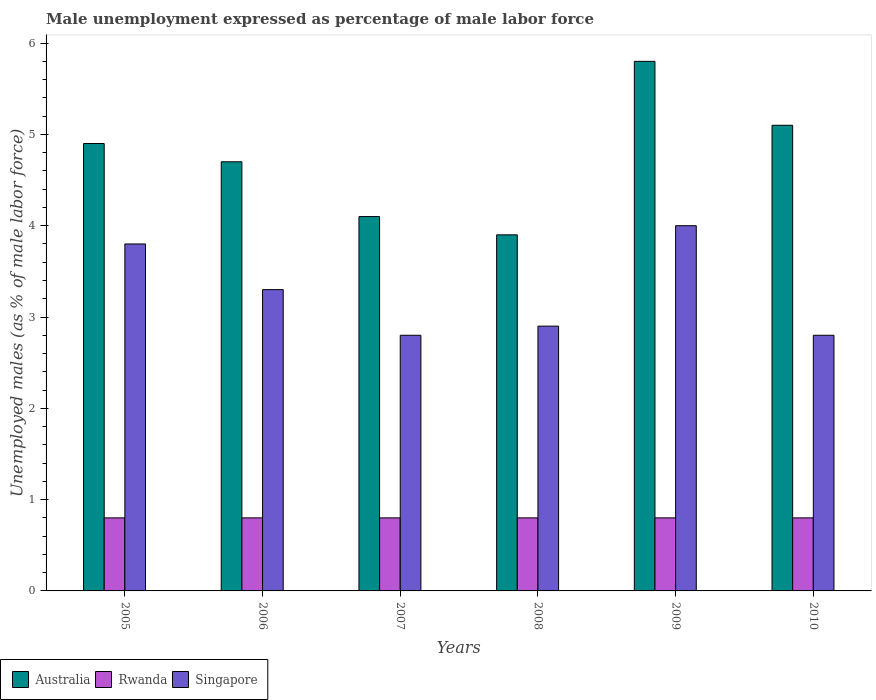How many groups of bars are there?
Offer a very short reply. 6. Are the number of bars per tick equal to the number of legend labels?
Offer a terse response. Yes. Are the number of bars on each tick of the X-axis equal?
Offer a very short reply. Yes. How many bars are there on the 3rd tick from the right?
Ensure brevity in your answer.  3. What is the label of the 2nd group of bars from the left?
Provide a succinct answer. 2006. What is the unemployment in males in in Australia in 2006?
Provide a short and direct response. 4.7. Across all years, what is the maximum unemployment in males in in Rwanda?
Keep it short and to the point. 0.8. Across all years, what is the minimum unemployment in males in in Singapore?
Offer a very short reply. 2.8. What is the total unemployment in males in in Rwanda in the graph?
Your response must be concise. 4.8. What is the difference between the unemployment in males in in Australia in 2005 and that in 2006?
Provide a short and direct response. 0.2. What is the difference between the unemployment in males in in Rwanda in 2007 and the unemployment in males in in Singapore in 2009?
Your response must be concise. -3.2. What is the average unemployment in males in in Rwanda per year?
Your answer should be compact. 0.8. In the year 2006, what is the difference between the unemployment in males in in Singapore and unemployment in males in in Australia?
Your answer should be compact. -1.4. In how many years, is the unemployment in males in in Singapore greater than 5 %?
Offer a very short reply. 0. What is the ratio of the unemployment in males in in Singapore in 2006 to that in 2010?
Provide a short and direct response. 1.18. Is the difference between the unemployment in males in in Singapore in 2007 and 2008 greater than the difference between the unemployment in males in in Australia in 2007 and 2008?
Keep it short and to the point. No. What is the difference between the highest and the second highest unemployment in males in in Singapore?
Provide a short and direct response. 0.2. What is the difference between the highest and the lowest unemployment in males in in Rwanda?
Give a very brief answer. 0. Is the sum of the unemployment in males in in Rwanda in 2006 and 2008 greater than the maximum unemployment in males in in Singapore across all years?
Offer a very short reply. No. What does the 2nd bar from the left in 2006 represents?
Provide a succinct answer. Rwanda. Is it the case that in every year, the sum of the unemployment in males in in Australia and unemployment in males in in Singapore is greater than the unemployment in males in in Rwanda?
Offer a very short reply. Yes. How many bars are there?
Give a very brief answer. 18. Are all the bars in the graph horizontal?
Provide a short and direct response. No. Are the values on the major ticks of Y-axis written in scientific E-notation?
Provide a short and direct response. No. Does the graph contain grids?
Ensure brevity in your answer.  No. How many legend labels are there?
Ensure brevity in your answer.  3. How are the legend labels stacked?
Offer a terse response. Horizontal. What is the title of the graph?
Provide a succinct answer. Male unemployment expressed as percentage of male labor force. What is the label or title of the X-axis?
Make the answer very short. Years. What is the label or title of the Y-axis?
Keep it short and to the point. Unemployed males (as % of male labor force). What is the Unemployed males (as % of male labor force) of Australia in 2005?
Keep it short and to the point. 4.9. What is the Unemployed males (as % of male labor force) in Rwanda in 2005?
Offer a very short reply. 0.8. What is the Unemployed males (as % of male labor force) of Singapore in 2005?
Provide a short and direct response. 3.8. What is the Unemployed males (as % of male labor force) in Australia in 2006?
Offer a terse response. 4.7. What is the Unemployed males (as % of male labor force) of Rwanda in 2006?
Your answer should be compact. 0.8. What is the Unemployed males (as % of male labor force) in Singapore in 2006?
Provide a succinct answer. 3.3. What is the Unemployed males (as % of male labor force) in Australia in 2007?
Your response must be concise. 4.1. What is the Unemployed males (as % of male labor force) in Rwanda in 2007?
Ensure brevity in your answer.  0.8. What is the Unemployed males (as % of male labor force) in Singapore in 2007?
Give a very brief answer. 2.8. What is the Unemployed males (as % of male labor force) in Australia in 2008?
Provide a succinct answer. 3.9. What is the Unemployed males (as % of male labor force) of Rwanda in 2008?
Your answer should be very brief. 0.8. What is the Unemployed males (as % of male labor force) in Singapore in 2008?
Your answer should be very brief. 2.9. What is the Unemployed males (as % of male labor force) in Australia in 2009?
Make the answer very short. 5.8. What is the Unemployed males (as % of male labor force) in Rwanda in 2009?
Provide a succinct answer. 0.8. What is the Unemployed males (as % of male labor force) of Australia in 2010?
Give a very brief answer. 5.1. What is the Unemployed males (as % of male labor force) in Rwanda in 2010?
Offer a terse response. 0.8. What is the Unemployed males (as % of male labor force) in Singapore in 2010?
Offer a very short reply. 2.8. Across all years, what is the maximum Unemployed males (as % of male labor force) of Australia?
Provide a succinct answer. 5.8. Across all years, what is the maximum Unemployed males (as % of male labor force) in Rwanda?
Ensure brevity in your answer.  0.8. Across all years, what is the minimum Unemployed males (as % of male labor force) in Australia?
Provide a succinct answer. 3.9. Across all years, what is the minimum Unemployed males (as % of male labor force) of Rwanda?
Provide a short and direct response. 0.8. Across all years, what is the minimum Unemployed males (as % of male labor force) in Singapore?
Offer a very short reply. 2.8. What is the total Unemployed males (as % of male labor force) in Australia in the graph?
Offer a very short reply. 28.5. What is the total Unemployed males (as % of male labor force) in Singapore in the graph?
Your response must be concise. 19.6. What is the difference between the Unemployed males (as % of male labor force) of Rwanda in 2005 and that in 2006?
Provide a succinct answer. 0. What is the difference between the Unemployed males (as % of male labor force) in Australia in 2005 and that in 2007?
Make the answer very short. 0.8. What is the difference between the Unemployed males (as % of male labor force) in Singapore in 2005 and that in 2007?
Offer a very short reply. 1. What is the difference between the Unemployed males (as % of male labor force) in Australia in 2005 and that in 2009?
Provide a succinct answer. -0.9. What is the difference between the Unemployed males (as % of male labor force) in Rwanda in 2005 and that in 2009?
Offer a very short reply. 0. What is the difference between the Unemployed males (as % of male labor force) of Singapore in 2005 and that in 2009?
Your answer should be very brief. -0.2. What is the difference between the Unemployed males (as % of male labor force) in Singapore in 2006 and that in 2007?
Make the answer very short. 0.5. What is the difference between the Unemployed males (as % of male labor force) of Australia in 2006 and that in 2008?
Your answer should be very brief. 0.8. What is the difference between the Unemployed males (as % of male labor force) in Australia in 2006 and that in 2009?
Ensure brevity in your answer.  -1.1. What is the difference between the Unemployed males (as % of male labor force) of Rwanda in 2006 and that in 2009?
Make the answer very short. 0. What is the difference between the Unemployed males (as % of male labor force) of Australia in 2006 and that in 2010?
Give a very brief answer. -0.4. What is the difference between the Unemployed males (as % of male labor force) of Singapore in 2007 and that in 2008?
Offer a terse response. -0.1. What is the difference between the Unemployed males (as % of male labor force) in Australia in 2007 and that in 2009?
Keep it short and to the point. -1.7. What is the difference between the Unemployed males (as % of male labor force) of Rwanda in 2007 and that in 2009?
Your answer should be very brief. 0. What is the difference between the Unemployed males (as % of male labor force) in Singapore in 2007 and that in 2009?
Your answer should be compact. -1.2. What is the difference between the Unemployed males (as % of male labor force) in Singapore in 2007 and that in 2010?
Provide a succinct answer. 0. What is the difference between the Unemployed males (as % of male labor force) of Australia in 2008 and that in 2009?
Make the answer very short. -1.9. What is the difference between the Unemployed males (as % of male labor force) of Rwanda in 2008 and that in 2009?
Offer a very short reply. 0. What is the difference between the Unemployed males (as % of male labor force) in Australia in 2008 and that in 2010?
Ensure brevity in your answer.  -1.2. What is the difference between the Unemployed males (as % of male labor force) in Rwanda in 2008 and that in 2010?
Give a very brief answer. 0. What is the difference between the Unemployed males (as % of male labor force) in Australia in 2009 and that in 2010?
Keep it short and to the point. 0.7. What is the difference between the Unemployed males (as % of male labor force) of Rwanda in 2009 and that in 2010?
Keep it short and to the point. 0. What is the difference between the Unemployed males (as % of male labor force) in Singapore in 2009 and that in 2010?
Your answer should be compact. 1.2. What is the difference between the Unemployed males (as % of male labor force) of Australia in 2005 and the Unemployed males (as % of male labor force) of Rwanda in 2007?
Your answer should be very brief. 4.1. What is the difference between the Unemployed males (as % of male labor force) in Australia in 2005 and the Unemployed males (as % of male labor force) in Rwanda in 2008?
Ensure brevity in your answer.  4.1. What is the difference between the Unemployed males (as % of male labor force) of Rwanda in 2005 and the Unemployed males (as % of male labor force) of Singapore in 2008?
Offer a very short reply. -2.1. What is the difference between the Unemployed males (as % of male labor force) in Australia in 2005 and the Unemployed males (as % of male labor force) in Rwanda in 2009?
Make the answer very short. 4.1. What is the difference between the Unemployed males (as % of male labor force) in Australia in 2005 and the Unemployed males (as % of male labor force) in Singapore in 2009?
Keep it short and to the point. 0.9. What is the difference between the Unemployed males (as % of male labor force) of Rwanda in 2005 and the Unemployed males (as % of male labor force) of Singapore in 2009?
Make the answer very short. -3.2. What is the difference between the Unemployed males (as % of male labor force) in Australia in 2005 and the Unemployed males (as % of male labor force) in Rwanda in 2010?
Give a very brief answer. 4.1. What is the difference between the Unemployed males (as % of male labor force) of Australia in 2006 and the Unemployed males (as % of male labor force) of Singapore in 2007?
Keep it short and to the point. 1.9. What is the difference between the Unemployed males (as % of male labor force) in Rwanda in 2006 and the Unemployed males (as % of male labor force) in Singapore in 2008?
Your response must be concise. -2.1. What is the difference between the Unemployed males (as % of male labor force) in Australia in 2006 and the Unemployed males (as % of male labor force) in Rwanda in 2009?
Keep it short and to the point. 3.9. What is the difference between the Unemployed males (as % of male labor force) in Australia in 2006 and the Unemployed males (as % of male labor force) in Singapore in 2009?
Offer a very short reply. 0.7. What is the difference between the Unemployed males (as % of male labor force) in Australia in 2006 and the Unemployed males (as % of male labor force) in Rwanda in 2010?
Your response must be concise. 3.9. What is the difference between the Unemployed males (as % of male labor force) of Rwanda in 2006 and the Unemployed males (as % of male labor force) of Singapore in 2010?
Ensure brevity in your answer.  -2. What is the difference between the Unemployed males (as % of male labor force) in Australia in 2007 and the Unemployed males (as % of male labor force) in Singapore in 2009?
Your answer should be very brief. 0.1. What is the difference between the Unemployed males (as % of male labor force) in Rwanda in 2007 and the Unemployed males (as % of male labor force) in Singapore in 2009?
Your answer should be compact. -3.2. What is the difference between the Unemployed males (as % of male labor force) in Rwanda in 2008 and the Unemployed males (as % of male labor force) in Singapore in 2009?
Ensure brevity in your answer.  -3.2. What is the difference between the Unemployed males (as % of male labor force) in Australia in 2008 and the Unemployed males (as % of male labor force) in Rwanda in 2010?
Ensure brevity in your answer.  3.1. What is the difference between the Unemployed males (as % of male labor force) of Australia in 2009 and the Unemployed males (as % of male labor force) of Singapore in 2010?
Offer a very short reply. 3. What is the average Unemployed males (as % of male labor force) of Australia per year?
Keep it short and to the point. 4.75. What is the average Unemployed males (as % of male labor force) of Singapore per year?
Your answer should be very brief. 3.27. In the year 2005, what is the difference between the Unemployed males (as % of male labor force) in Australia and Unemployed males (as % of male labor force) in Rwanda?
Your answer should be very brief. 4.1. In the year 2006, what is the difference between the Unemployed males (as % of male labor force) of Australia and Unemployed males (as % of male labor force) of Rwanda?
Your response must be concise. 3.9. In the year 2006, what is the difference between the Unemployed males (as % of male labor force) in Rwanda and Unemployed males (as % of male labor force) in Singapore?
Provide a succinct answer. -2.5. In the year 2007, what is the difference between the Unemployed males (as % of male labor force) of Australia and Unemployed males (as % of male labor force) of Singapore?
Your response must be concise. 1.3. In the year 2008, what is the difference between the Unemployed males (as % of male labor force) of Rwanda and Unemployed males (as % of male labor force) of Singapore?
Offer a terse response. -2.1. In the year 2009, what is the difference between the Unemployed males (as % of male labor force) in Australia and Unemployed males (as % of male labor force) in Singapore?
Provide a succinct answer. 1.8. In the year 2010, what is the difference between the Unemployed males (as % of male labor force) of Australia and Unemployed males (as % of male labor force) of Rwanda?
Offer a terse response. 4.3. In the year 2010, what is the difference between the Unemployed males (as % of male labor force) in Australia and Unemployed males (as % of male labor force) in Singapore?
Your response must be concise. 2.3. What is the ratio of the Unemployed males (as % of male labor force) in Australia in 2005 to that in 2006?
Your answer should be compact. 1.04. What is the ratio of the Unemployed males (as % of male labor force) of Rwanda in 2005 to that in 2006?
Provide a succinct answer. 1. What is the ratio of the Unemployed males (as % of male labor force) in Singapore in 2005 to that in 2006?
Keep it short and to the point. 1.15. What is the ratio of the Unemployed males (as % of male labor force) of Australia in 2005 to that in 2007?
Your response must be concise. 1.2. What is the ratio of the Unemployed males (as % of male labor force) of Singapore in 2005 to that in 2007?
Ensure brevity in your answer.  1.36. What is the ratio of the Unemployed males (as % of male labor force) in Australia in 2005 to that in 2008?
Offer a terse response. 1.26. What is the ratio of the Unemployed males (as % of male labor force) in Rwanda in 2005 to that in 2008?
Provide a short and direct response. 1. What is the ratio of the Unemployed males (as % of male labor force) in Singapore in 2005 to that in 2008?
Offer a very short reply. 1.31. What is the ratio of the Unemployed males (as % of male labor force) in Australia in 2005 to that in 2009?
Ensure brevity in your answer.  0.84. What is the ratio of the Unemployed males (as % of male labor force) of Rwanda in 2005 to that in 2009?
Your response must be concise. 1. What is the ratio of the Unemployed males (as % of male labor force) in Singapore in 2005 to that in 2009?
Provide a short and direct response. 0.95. What is the ratio of the Unemployed males (as % of male labor force) of Australia in 2005 to that in 2010?
Keep it short and to the point. 0.96. What is the ratio of the Unemployed males (as % of male labor force) in Singapore in 2005 to that in 2010?
Make the answer very short. 1.36. What is the ratio of the Unemployed males (as % of male labor force) in Australia in 2006 to that in 2007?
Keep it short and to the point. 1.15. What is the ratio of the Unemployed males (as % of male labor force) in Singapore in 2006 to that in 2007?
Your answer should be very brief. 1.18. What is the ratio of the Unemployed males (as % of male labor force) of Australia in 2006 to that in 2008?
Your answer should be compact. 1.21. What is the ratio of the Unemployed males (as % of male labor force) in Singapore in 2006 to that in 2008?
Ensure brevity in your answer.  1.14. What is the ratio of the Unemployed males (as % of male labor force) in Australia in 2006 to that in 2009?
Provide a succinct answer. 0.81. What is the ratio of the Unemployed males (as % of male labor force) of Rwanda in 2006 to that in 2009?
Keep it short and to the point. 1. What is the ratio of the Unemployed males (as % of male labor force) of Singapore in 2006 to that in 2009?
Offer a terse response. 0.82. What is the ratio of the Unemployed males (as % of male labor force) in Australia in 2006 to that in 2010?
Ensure brevity in your answer.  0.92. What is the ratio of the Unemployed males (as % of male labor force) of Rwanda in 2006 to that in 2010?
Provide a short and direct response. 1. What is the ratio of the Unemployed males (as % of male labor force) of Singapore in 2006 to that in 2010?
Your answer should be compact. 1.18. What is the ratio of the Unemployed males (as % of male labor force) in Australia in 2007 to that in 2008?
Your response must be concise. 1.05. What is the ratio of the Unemployed males (as % of male labor force) of Singapore in 2007 to that in 2008?
Your response must be concise. 0.97. What is the ratio of the Unemployed males (as % of male labor force) of Australia in 2007 to that in 2009?
Keep it short and to the point. 0.71. What is the ratio of the Unemployed males (as % of male labor force) of Rwanda in 2007 to that in 2009?
Your answer should be compact. 1. What is the ratio of the Unemployed males (as % of male labor force) of Australia in 2007 to that in 2010?
Keep it short and to the point. 0.8. What is the ratio of the Unemployed males (as % of male labor force) in Rwanda in 2007 to that in 2010?
Your answer should be very brief. 1. What is the ratio of the Unemployed males (as % of male labor force) in Australia in 2008 to that in 2009?
Make the answer very short. 0.67. What is the ratio of the Unemployed males (as % of male labor force) in Singapore in 2008 to that in 2009?
Make the answer very short. 0.72. What is the ratio of the Unemployed males (as % of male labor force) in Australia in 2008 to that in 2010?
Ensure brevity in your answer.  0.76. What is the ratio of the Unemployed males (as % of male labor force) in Rwanda in 2008 to that in 2010?
Provide a succinct answer. 1. What is the ratio of the Unemployed males (as % of male labor force) in Singapore in 2008 to that in 2010?
Your answer should be compact. 1.04. What is the ratio of the Unemployed males (as % of male labor force) of Australia in 2009 to that in 2010?
Your response must be concise. 1.14. What is the ratio of the Unemployed males (as % of male labor force) of Singapore in 2009 to that in 2010?
Provide a short and direct response. 1.43. What is the difference between the highest and the lowest Unemployed males (as % of male labor force) in Australia?
Your answer should be compact. 1.9. What is the difference between the highest and the lowest Unemployed males (as % of male labor force) in Rwanda?
Provide a succinct answer. 0. 